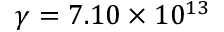<formula> <loc_0><loc_0><loc_500><loc_500>\gamma = 7 . 1 0 \times 1 0 ^ { 1 3 }</formula> 